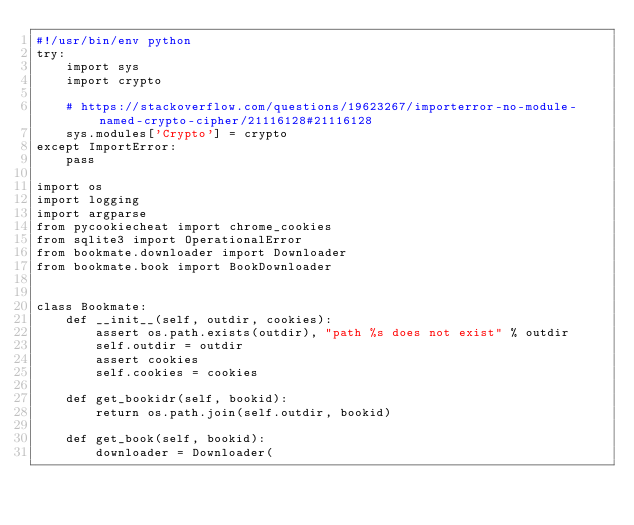Convert code to text. <code><loc_0><loc_0><loc_500><loc_500><_Python_>#!/usr/bin/env python
try:
    import sys
    import crypto

    # https://stackoverflow.com/questions/19623267/importerror-no-module-named-crypto-cipher/21116128#21116128
    sys.modules['Crypto'] = crypto
except ImportError:
    pass

import os
import logging
import argparse
from pycookiecheat import chrome_cookies
from sqlite3 import OperationalError
from bookmate.downloader import Downloader
from bookmate.book import BookDownloader


class Bookmate:
    def __init__(self, outdir, cookies):
        assert os.path.exists(outdir), "path %s does not exist" % outdir
        self.outdir = outdir
        assert cookies
        self.cookies = cookies

    def get_bookidr(self, bookid):
        return os.path.join(self.outdir, bookid)

    def get_book(self, bookid):
        downloader = Downloader(</code> 